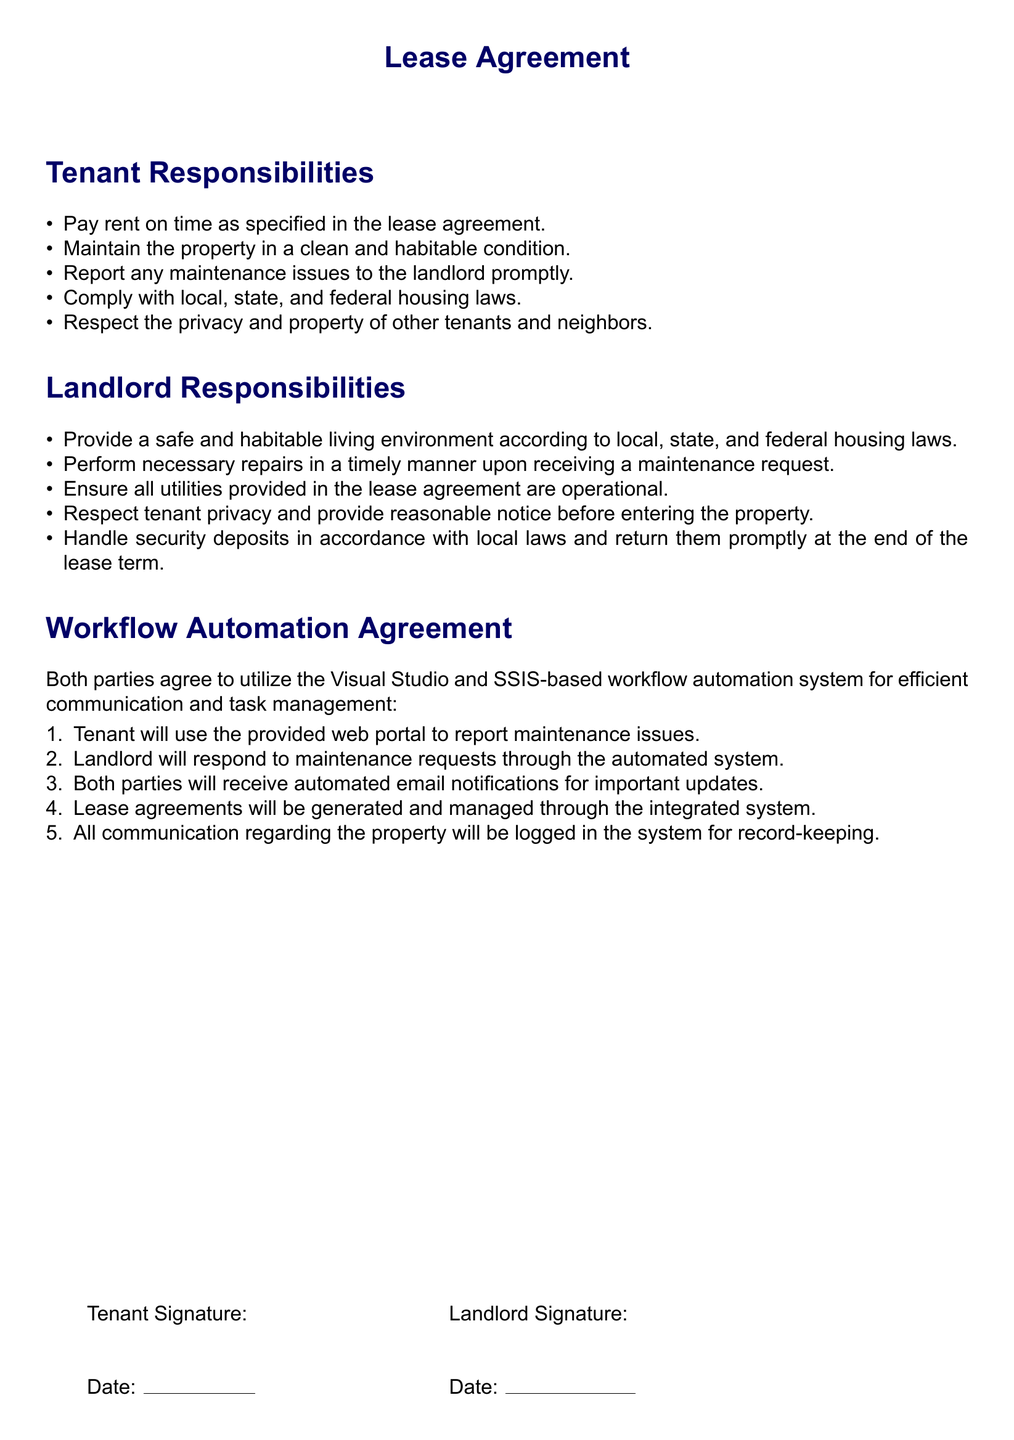What is the tenant's first responsibility? The first responsibility of the tenant is to pay rent on time as specified in the lease agreement.
Answer: Pay rent on time What must the landlord provide according to their responsibilities? The landlord must provide a safe and habitable living environment according to local, state, and federal housing laws.
Answer: Safe and habitable living environment How will maintenance issues be reported by the tenant? The tenant will use the provided web portal to report maintenance issues.
Answer: Web portal What type of system will be used for communication? An SSIS-based workflow automation system will be utilized for efficient communication and task management.
Answer: SSIS-based workflow automation system What must the landlord do upon receiving a maintenance request? The landlord must perform necessary repairs in a timely manner.
Answer: Perform necessary repairs promptly How will important updates be communicated to both parties? Both parties will receive automated email notifications for important updates.
Answer: Automated email notifications What is expected from tenants regarding their neighbors? Tenants are expected to respect the privacy and property of other tenants and neighbors.
Answer: Respect privacy and property How are security deposits handled according to landlord responsibilities? Security deposits must be handled in accordance with local laws and returned promptly at the end of the lease term.
Answer: In accordance with local laws What will happen to communication regarding the property? All communication regarding the property will be logged in the system for record-keeping.
Answer: Logged in the system 